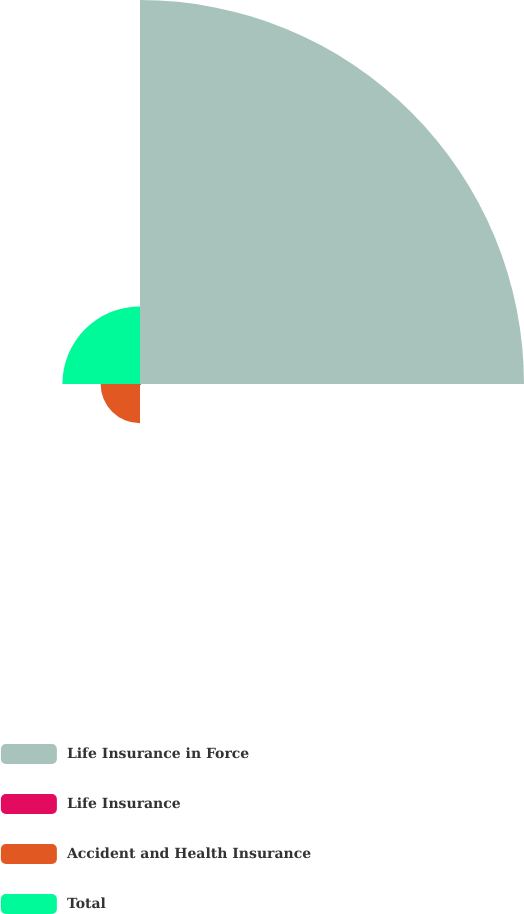Convert chart. <chart><loc_0><loc_0><loc_500><loc_500><pie_chart><fcel>Life Insurance in Force<fcel>Life Insurance<fcel>Accident and Health Insurance<fcel>Total<nl><fcel>76.49%<fcel>0.21%<fcel>7.84%<fcel>15.46%<nl></chart> 